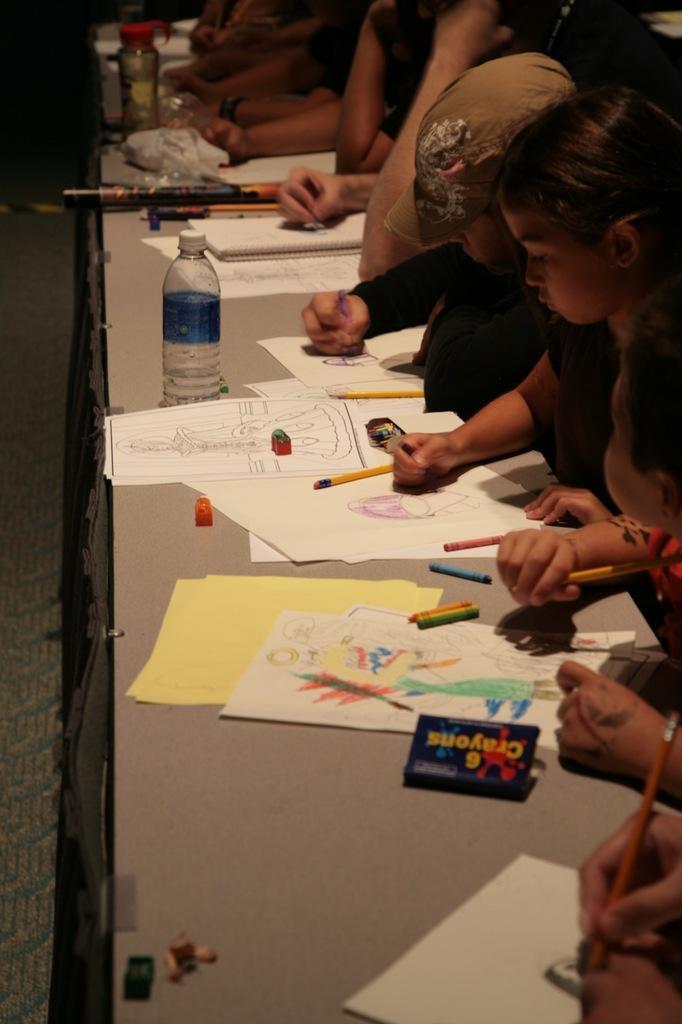Could you give a brief overview of what you see in this image? In the image there is a long table and there are a group of kids sitting in front of the table and they are drawing some images on the papers, on the table there are papers, crayons, bottles and other things. 